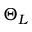Convert formula to latex. <formula><loc_0><loc_0><loc_500><loc_500>\Theta _ { L }</formula> 